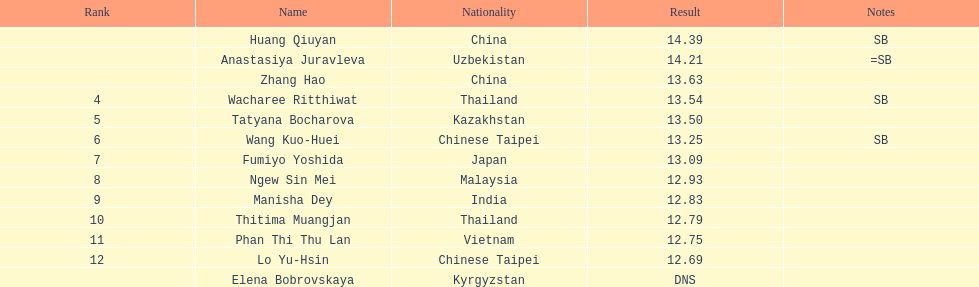Could you parse the entire table? {'header': ['Rank', 'Name', 'Nationality', 'Result', 'Notes'], 'rows': [['', 'Huang Qiuyan', 'China', '14.39', 'SB'], ['', 'Anastasiya Juravleva', 'Uzbekistan', '14.21', '=SB'], ['', 'Zhang Hao', 'China', '13.63', ''], ['4', 'Wacharee Ritthiwat', 'Thailand', '13.54', 'SB'], ['5', 'Tatyana Bocharova', 'Kazakhstan', '13.50', ''], ['6', 'Wang Kuo-Huei', 'Chinese Taipei', '13.25', 'SB'], ['7', 'Fumiyo Yoshida', 'Japan', '13.09', ''], ['8', 'Ngew Sin Mei', 'Malaysia', '12.93', ''], ['9', 'Manisha Dey', 'India', '12.83', ''], ['10', 'Thitima Muangjan', 'Thailand', '12.79', ''], ['11', 'Phan Thi Thu Lan', 'Vietnam', '12.75', ''], ['12', 'Lo Yu-Hsin', 'Chinese Taipei', '12.69', ''], ['', 'Elena Bobrovskaya', 'Kyrgyzstan', 'DNS', '']]} During the event, which country had the largest number of competitors ranking in the top three? China. 